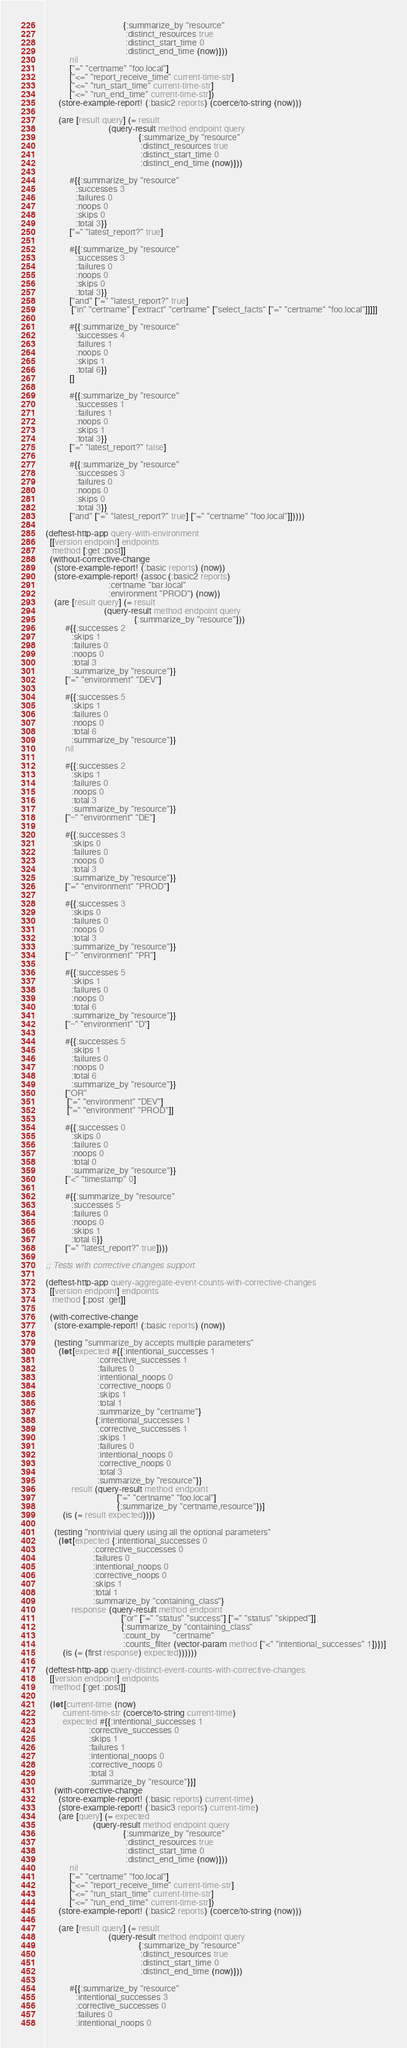Convert code to text. <code><loc_0><loc_0><loc_500><loc_500><_Clojure_>                                    {:summarize_by "resource"
                                     :distinct_resources true
                                     :distinct_start_time 0
                                     :distinct_end_time (now)}))
           nil
           ["=" "certname" "foo.local"]
           ["<=" "report_receive_time" current-time-str]
           ["<=" "run_start_time" current-time-str]
           ["<=" "run_end_time" current-time-str])
      (store-example-report! (:basic2 reports) (coerce/to-string (now)))

      (are [result query] (= result
                             (query-result method endpoint query
                                           {:summarize_by "resource"
                                            :distinct_resources true
                                            :distinct_start_time 0
                                            :distinct_end_time (now)}))

           #{{:summarize_by "resource"
              :successes 3
              :failures 0
              :noops 0
              :skips 0
              :total 3}}
           ["=" "latest_report?" true]

           #{{:summarize_by "resource"
              :successes 3
              :failures 0
              :noops 0
              :skips 0
              :total 3}}
           ["and" ["=" "latest_report?" true]
            ["in" "certname" ["extract" "certname" ["select_facts" ["=" "certname" "foo.local"]]]]]

           #{{:summarize_by "resource"
              :successes 4
              :failures 1
              :noops 0
              :skips 1
              :total 6}}
           []

           #{{:summarize_by "resource"
              :successes 1
              :failures 1
              :noops 0
              :skips 1
              :total 3}}
           ["=" "latest_report?" false]

           #{{:summarize_by "resource"
              :successes 3
              :failures 0
              :noops 0
              :skips 0
              :total 3}}
           ["and" ["=" "latest_report?" true] ["=" "certname" "foo.local"]]))))

(deftest-http-app query-with-environment
  [[version endpoint] endpoints
   method [:get :post]]
  (without-corrective-change
    (store-example-report! (:basic reports) (now))
    (store-example-report! (assoc (:basic2 reports)
                             :certname "bar.local"
                             :environment "PROD") (now))
    (are [result query] (= result
                           (query-result method endpoint query
                                         {:summarize_by "resource"}))
         #{{:successes 2
            :skips 1
            :failures 0
            :noops 0
            :total 3
            :summarize_by "resource"}}
         ["=" "environment" "DEV"]

         #{{:successes 5
            :skips 1
            :failures 0
            :noops 0
            :total 6
            :summarize_by "resource"}}
         nil

         #{{:successes 2
            :skips 1
            :failures 0
            :noops 0
            :total 3
            :summarize_by "resource"}}
         ["~" "environment" "DE"]

         #{{:successes 3
            :skips 0
            :failures 0
            :noops 0
            :total 3
            :summarize_by "resource"}}
         ["=" "environment" "PROD"]

         #{{:successes 3
            :skips 0
            :failures 0
            :noops 0
            :total 3
            :summarize_by "resource"}}
         ["~" "environment" "PR"]

         #{{:successes 5
            :skips 1
            :failures 0
            :noops 0
            :total 6
            :summarize_by "resource"}}
         ["~" "environment" "D"]

         #{{:successes 5
            :skips 1
            :failures 0
            :noops 0
            :total 6
            :summarize_by "resource"}}
         ["OR"
          ["=" "environment" "DEV"]
          ["=" "environment" "PROD"]]

         #{{:successes 0
            :skips 0
            :failures 0
            :noops 0
            :total 0
            :summarize_by "resource"}}
         ["<" "timestamp" 0]

         #{{:summarize_by "resource"
            :successes 5
            :failures 0
            :noops 0
            :skips 1
            :total 6}}
         ["=" "latest_report?" true])))

;; Tests with corrective changes support

(deftest-http-app query-aggregate-event-counts-with-corrective-changes
  [[version endpoint] endpoints
   method [:post :get]]

  (with-corrective-change
    (store-example-report! (:basic reports) (now))

    (testing "summarize_by accepts multiple parameters"
      (let [expected #{{:intentional_successes 1
                        :corrective_successes 1
                        :failures 0
                        :intentional_noops 0
                        :corrective_noops 0
                        :skips 1
                        :total 1
                        :summarize_by "certname"}
                       {:intentional_successes 1
                        :corrective_successes 1
                        :skips 1
                        :failures 0
                        :intentional_noops 0
                        :corrective_noops 0
                        :total 3
                        :summarize_by "resource"}}
            result (query-result method endpoint
                                 ["=" "certname" "foo.local"]
                                 {:summarize_by "certname,resource"})]
        (is (= result expected))))

    (testing "nontrivial query using all the optional parameters"
      (let [expected {:intentional_successes 0
                      :corrective_successes 0
                      :failures 0
                      :intentional_noops 0
                      :corrective_noops 0
                      :skips 1
                      :total 1
                      :summarize_by "containing_class"}
            response (query-result method endpoint
                                   ["or" ["=" "status" "success"] ["=" "status" "skipped"]]
                                   {:summarize_by "containing_class"
                                    :count_by      "certname"
                                    :counts_filter (vector-param method ["<" "intentional_successes" 1])})]
        (is (= (first response) expected))))))

(deftest-http-app query-distinct-event-counts-with-corrective-changes
  [[version endpoint] endpoints
   method [:get :post]]

  (let [current-time (now)
        current-time-str (coerce/to-string current-time)
        expected #{{:intentional_successes 1
                    :corrective_successes 0
                    :skips 1
                    :failures 1
                    :intentional_noops 0
                    :corrective_noops 0
                    :total 3
                    :summarize_by "resource"}}]
    (with-corrective-change
      (store-example-report! (:basic reports) current-time)
      (store-example-report! (:basic3 reports) current-time)
      (are [query] (= expected
                      (query-result method endpoint query
                                    {:summarize_by "resource"
                                     :distinct_resources true
                                     :distinct_start_time 0
                                     :distinct_end_time (now)}))
           nil
           ["=" "certname" "foo.local"]
           ["<=" "report_receive_time" current-time-str]
           ["<=" "run_start_time" current-time-str]
           ["<=" "run_end_time" current-time-str])
      (store-example-report! (:basic2 reports) (coerce/to-string (now)))

      (are [result query] (= result
                             (query-result method endpoint query
                                           {:summarize_by "resource"
                                            :distinct_resources true
                                            :distinct_start_time 0
                                            :distinct_end_time (now)}))

           #{{:summarize_by "resource"
              :intentional_successes 3
              :corrective_successes 0
              :failures 0
              :intentional_noops 0</code> 